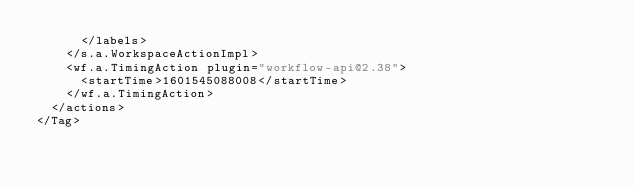Convert code to text. <code><loc_0><loc_0><loc_500><loc_500><_XML_>      </labels>
    </s.a.WorkspaceActionImpl>
    <wf.a.TimingAction plugin="workflow-api@2.38">
      <startTime>1601545088008</startTime>
    </wf.a.TimingAction>
  </actions>
</Tag></code> 